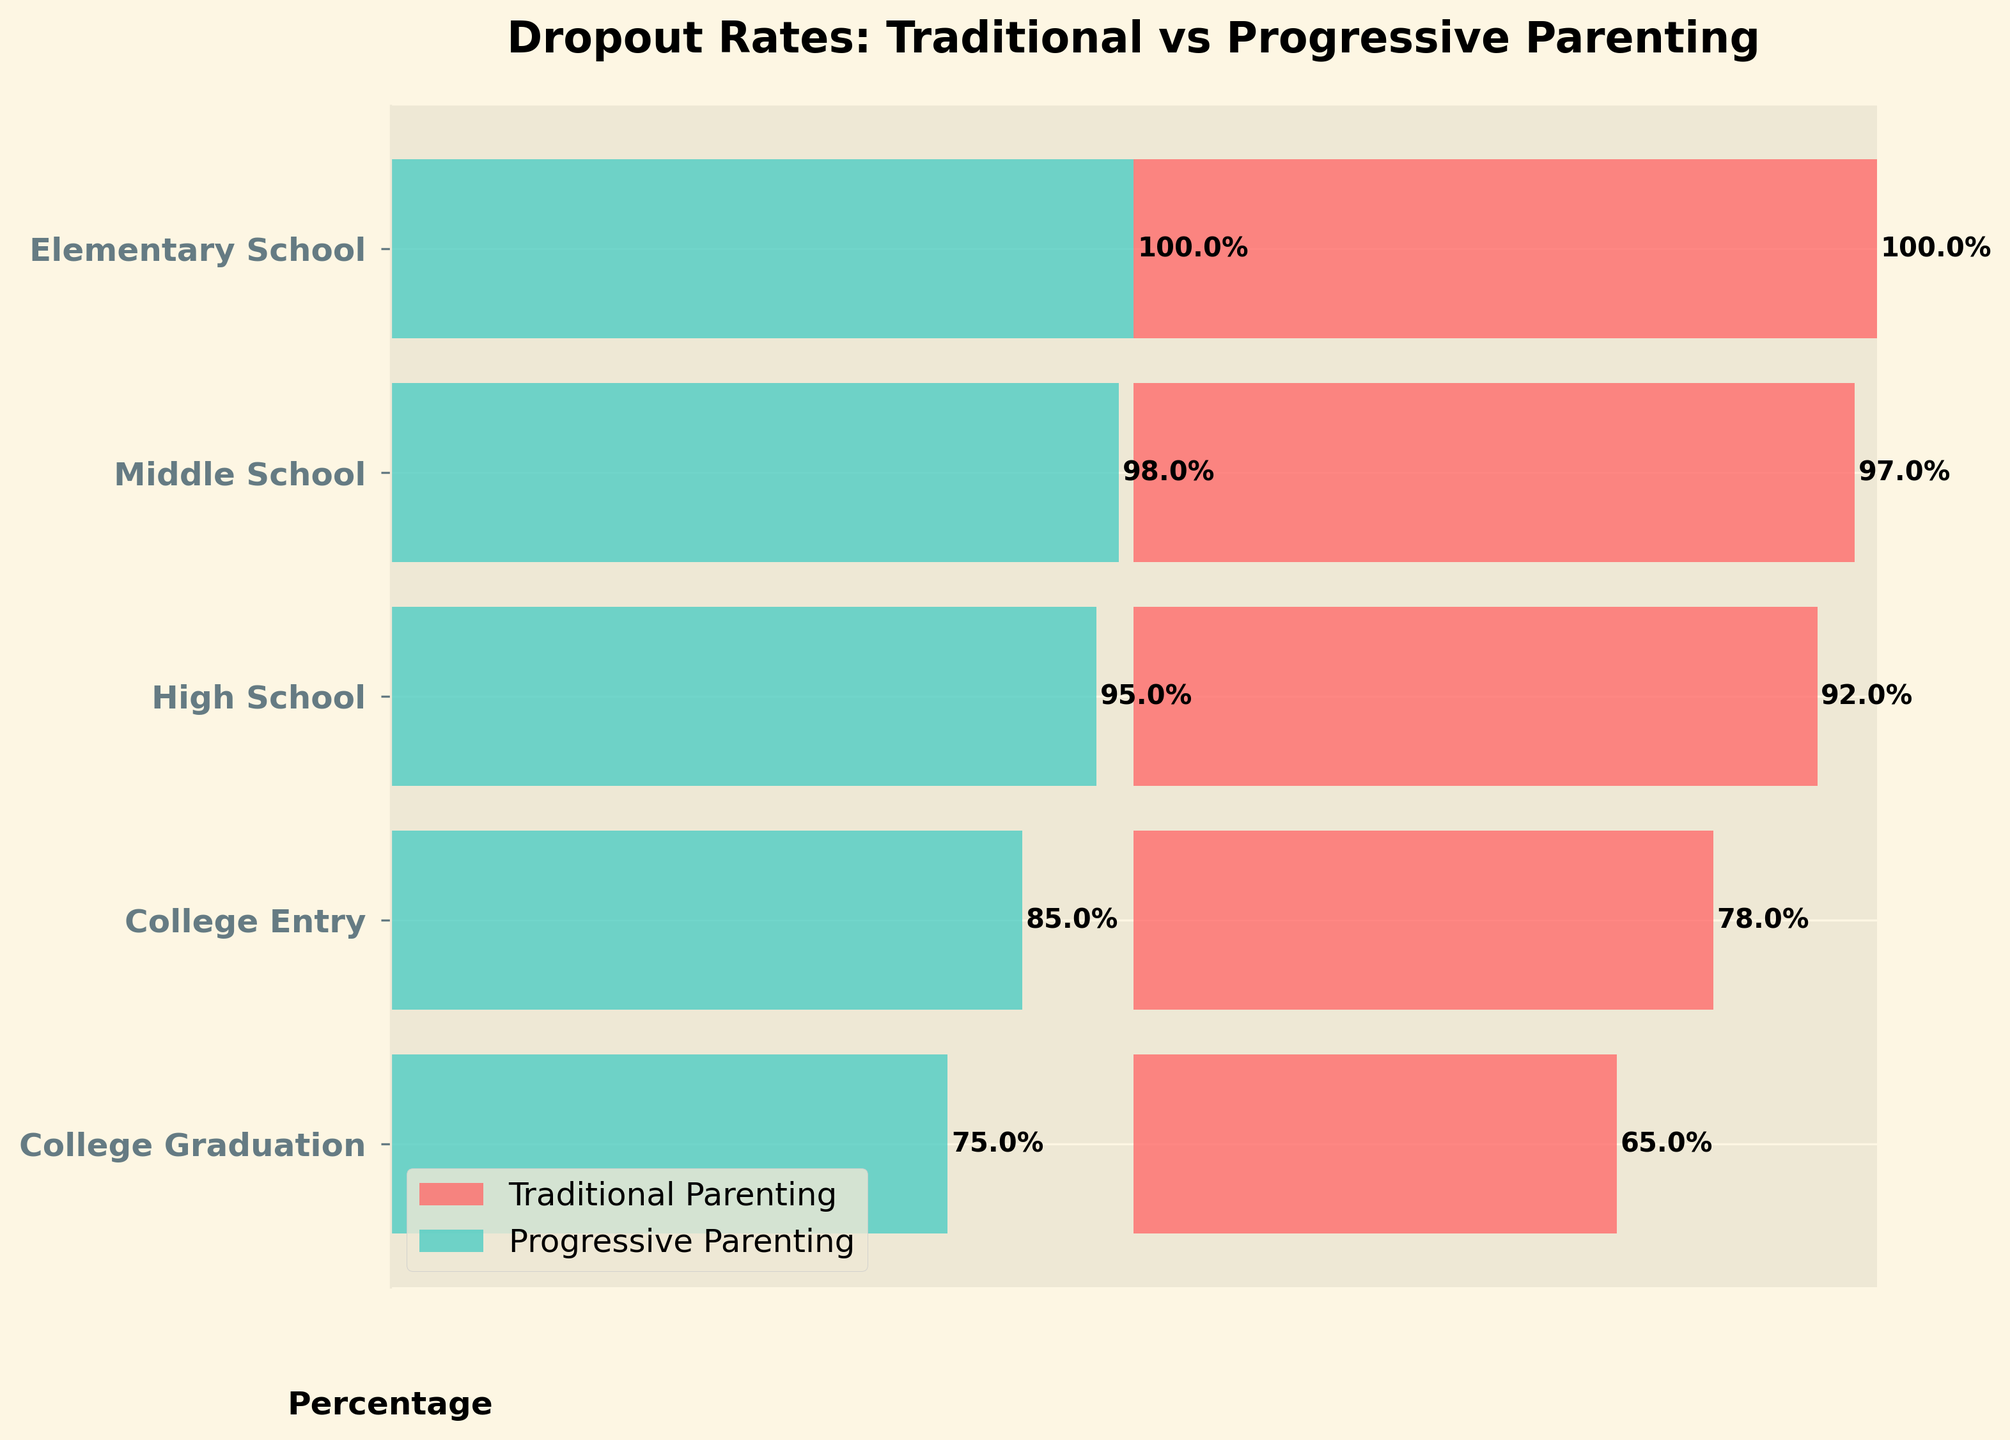What's the title of the figure? The title is located at the top of the figure and provides a summary of the data being shown. In this case, reading the title will give us an understanding of what the figure is about.
Answer: Dropout Rates: Traditional vs Progressive Parenting How many stages of education are represented in the figure? The stages of education are listed on the y-axis of the funnel chart. Counting these labels will provide the number of stages presented.
Answer: 5 Which type of parenting shows a higher dropout rate at the College Graduation stage? At the College Graduation stage, compare the percentage values of both traditional and progressive parenting. The higher percentage indicates the higher dropout rate.
Answer: Traditional Parenting What is the dropout rate difference at the College Entry stage between the two parenting styles? At the College Entry stage, subtract the dropout rate of progressive parenting from traditional parenting to find the difference.
Answer: 78% - 85% = -7% Which educational stage has the smallest dropout rate difference between the two parenting styles? Calculate the absolute difference between the dropout rates of traditional and progressive parenting for each educational stage, then identify the smallest difference.
Answer: Middle School (1%) At which educational stage does traditional parenting see the largest drop in dropout rates compared to the previous stage? Calculate the difference in dropout rates between each consecutive stage for traditional parenting, then identify the stage with the largest drop.
Answer: College Entry (14%) On average, which parenting style has a higher dropout rate across all educational stages? Calculate the average dropout rate for both parenting styles by summing their respective percentages across all stages and dividing by the number of stages, then compare the two averages.
Answer: Traditional Parenting How does the dropout rate trend differ from Elementary School to College Graduation for both parenting styles? Observe the dropout rate percentages from Elementary School to College Graduation for both parenting styles. Note the trend (increasing or decreasing) across the stages.
Answer: Traditional Parenting shows a consistently decreasing trend, while Progressive Parenting also shows a decreasing trend but at a different rate Which parenting style has a better retention rate at the High School stage? Compare the dropout rates of both parenting styles at the High School stage, where the lower percentage indicates a better retention rate.
Answer: Progressive Parenting 